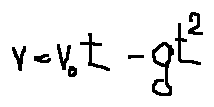<formula> <loc_0><loc_0><loc_500><loc_500>v = v _ { 0 } t - g t ^ { 2 }</formula> 